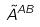<formula> <loc_0><loc_0><loc_500><loc_500>\tilde { A } ^ { A B }</formula> 